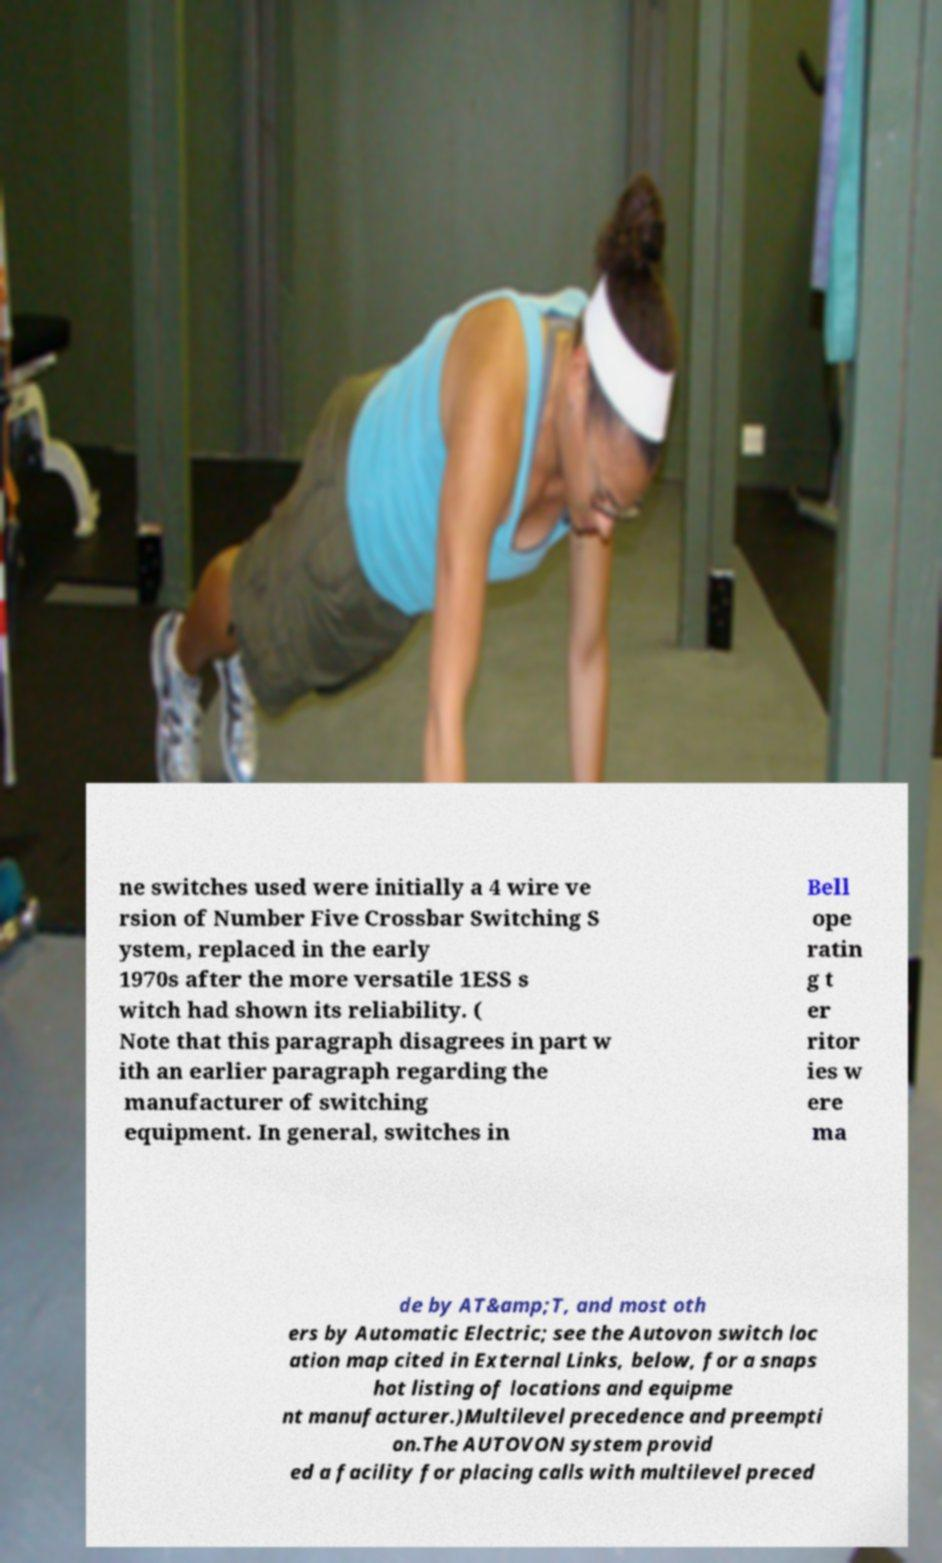I need the written content from this picture converted into text. Can you do that? ne switches used were initially a 4 wire ve rsion of Number Five Crossbar Switching S ystem, replaced in the early 1970s after the more versatile 1ESS s witch had shown its reliability. ( Note that this paragraph disagrees in part w ith an earlier paragraph regarding the manufacturer of switching equipment. In general, switches in Bell ope ratin g t er ritor ies w ere ma de by AT&amp;T, and most oth ers by Automatic Electric; see the Autovon switch loc ation map cited in External Links, below, for a snaps hot listing of locations and equipme nt manufacturer.)Multilevel precedence and preempti on.The AUTOVON system provid ed a facility for placing calls with multilevel preced 